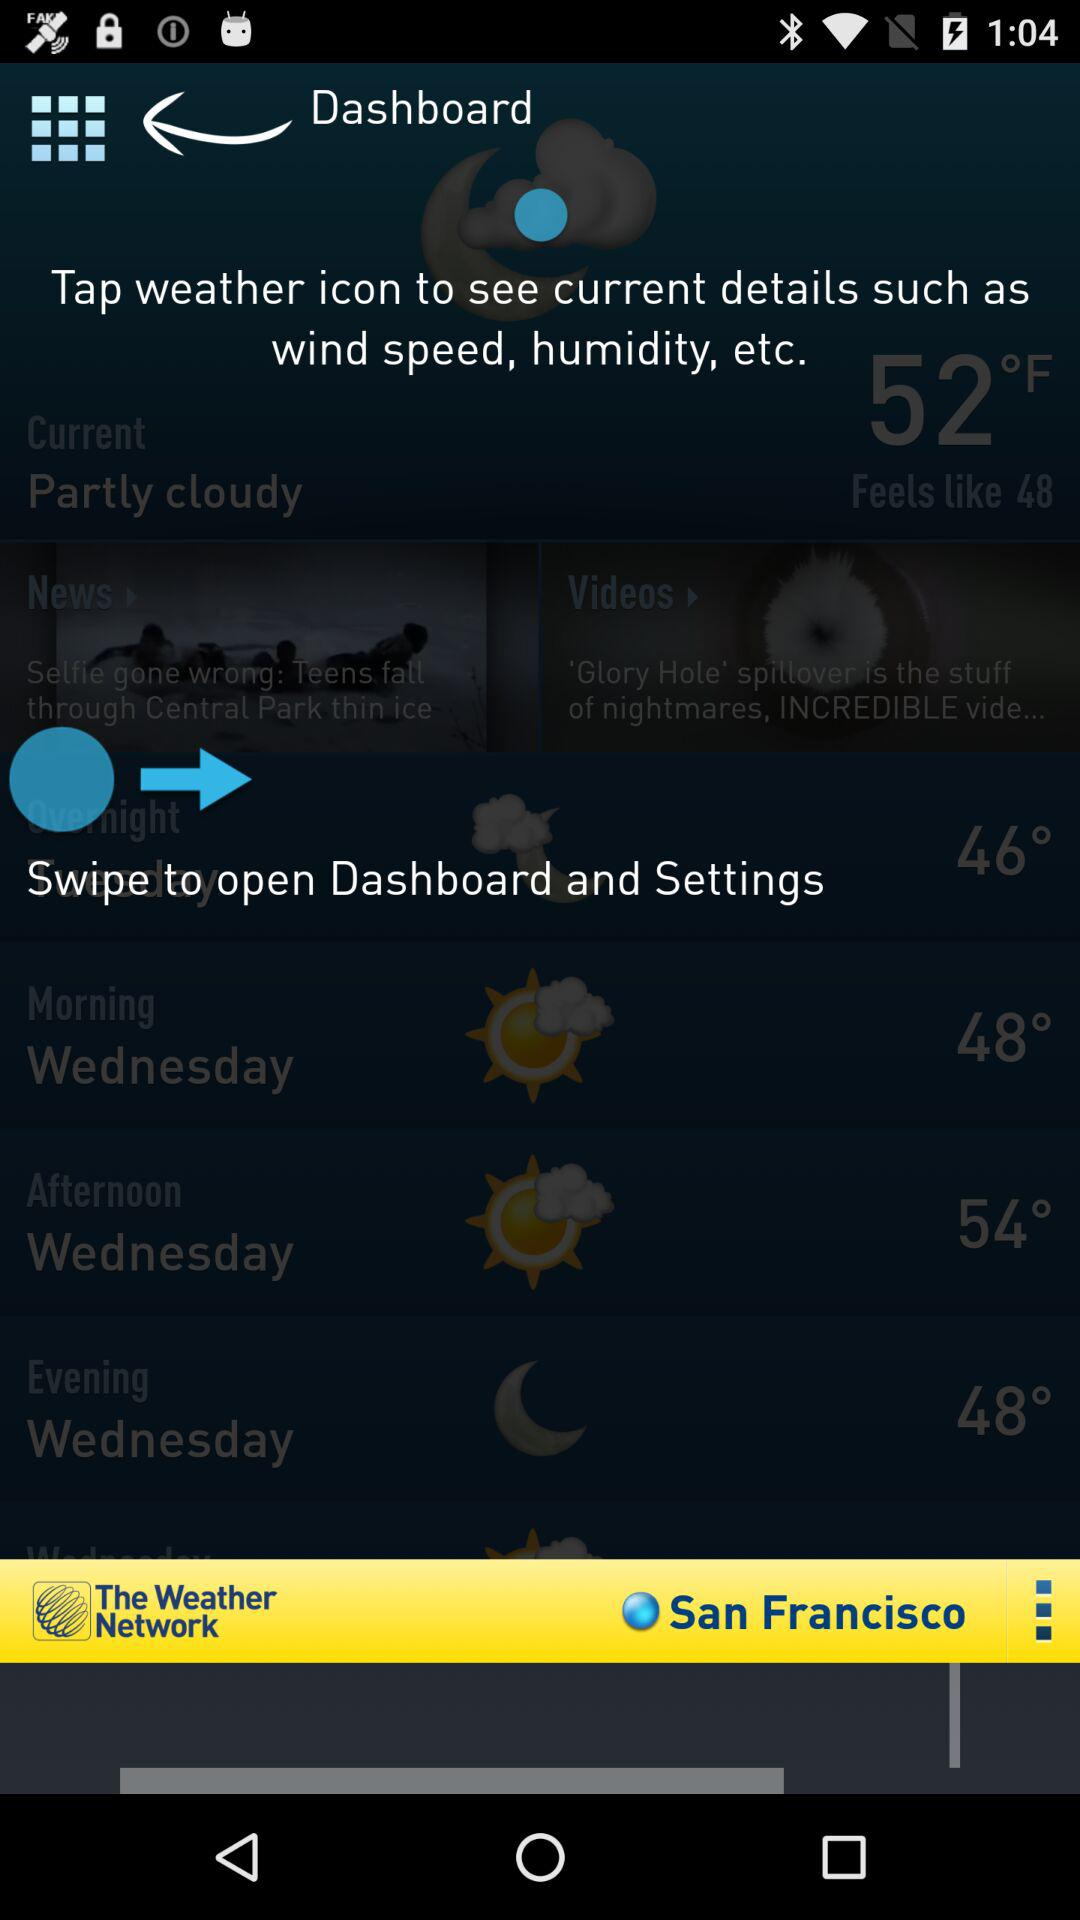What location is mentioned? The mentioned location is San Francisco. 